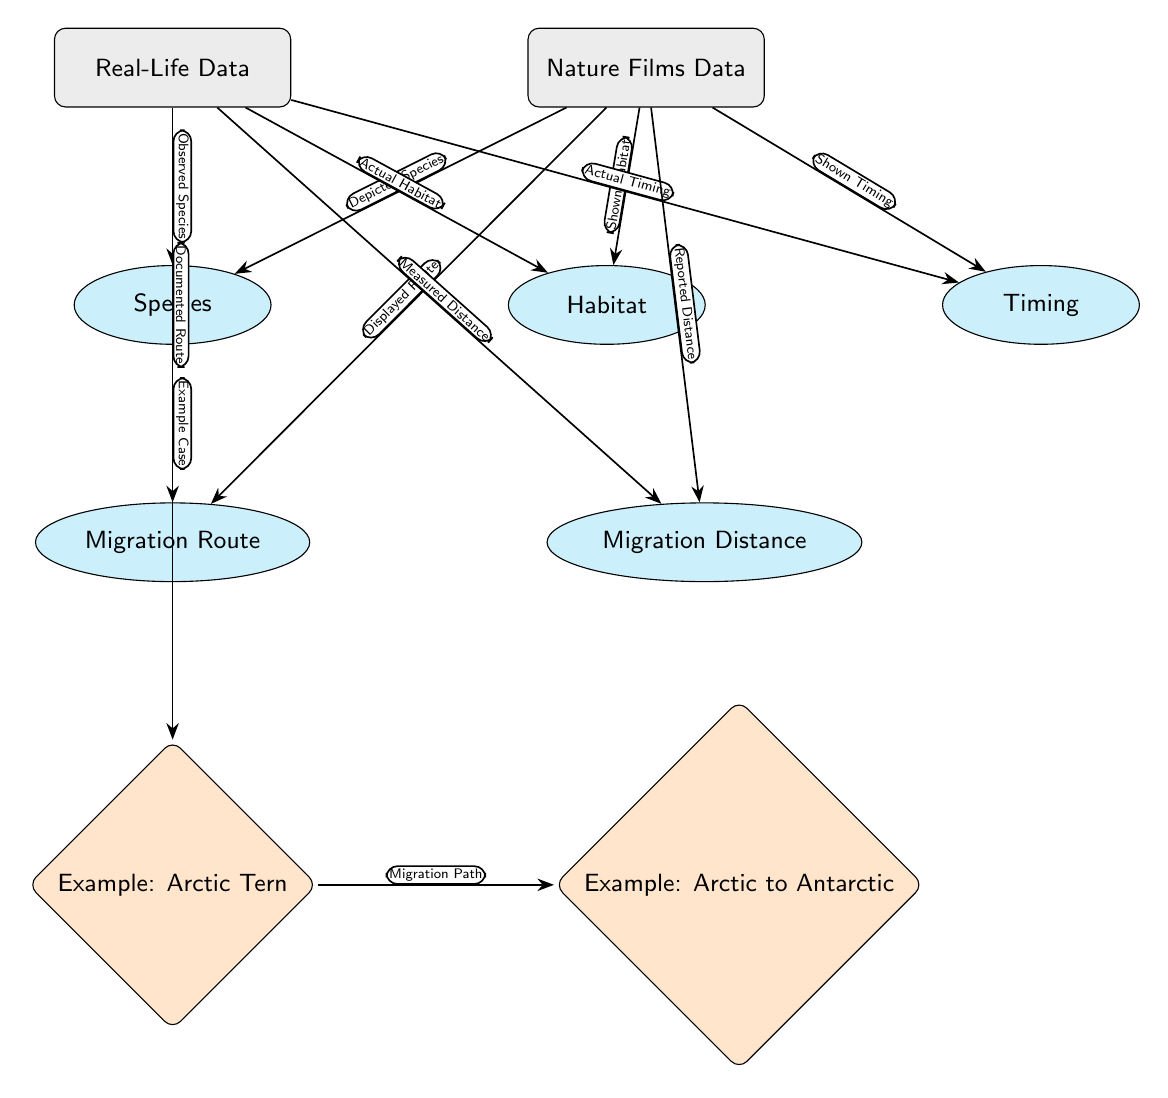What nodes are connected to Real-Life Data? The diagram shows that Real-Life Data connects to five nodes: Species, Habitat, Timing, Migration Route, and Migration Distance. These connections indicate the various categories in which real-life migration patterns are documented.
Answer: Species, Habitat, Timing, Migration Route, Migration Distance How many example species are displayed in the diagram? The diagram presents one example species, the Arctic Tern, which is displayed as an example case under Real-Life Data and is linked to its migration path to the Antarctic.
Answer: One What kind of species does the Nature Films Data node depict? The Nature Films Data node is linked to the Depicted Species edge, which indicates that it encapsulates species as shown in nature films, contrasting with the observed species in real life.
Answer: Depicted Species What is the relationship between Documented Route and Displayed Route? Documented Route refers to the actual migration routes as observed in real-life data, while Displayed Route refers to how these routes are portrayed in nature films, indicating a comparative approach between real and depicted data.
Answer: Actual vs. Shown What does the edge label "Measured Distance" refer to in the diagram? The edge labeled "Measured Distance" connects Real-Life Data to the Migration Distance category, suggesting it represents the actual distances that birds migrate.
Answer: Actual distances 